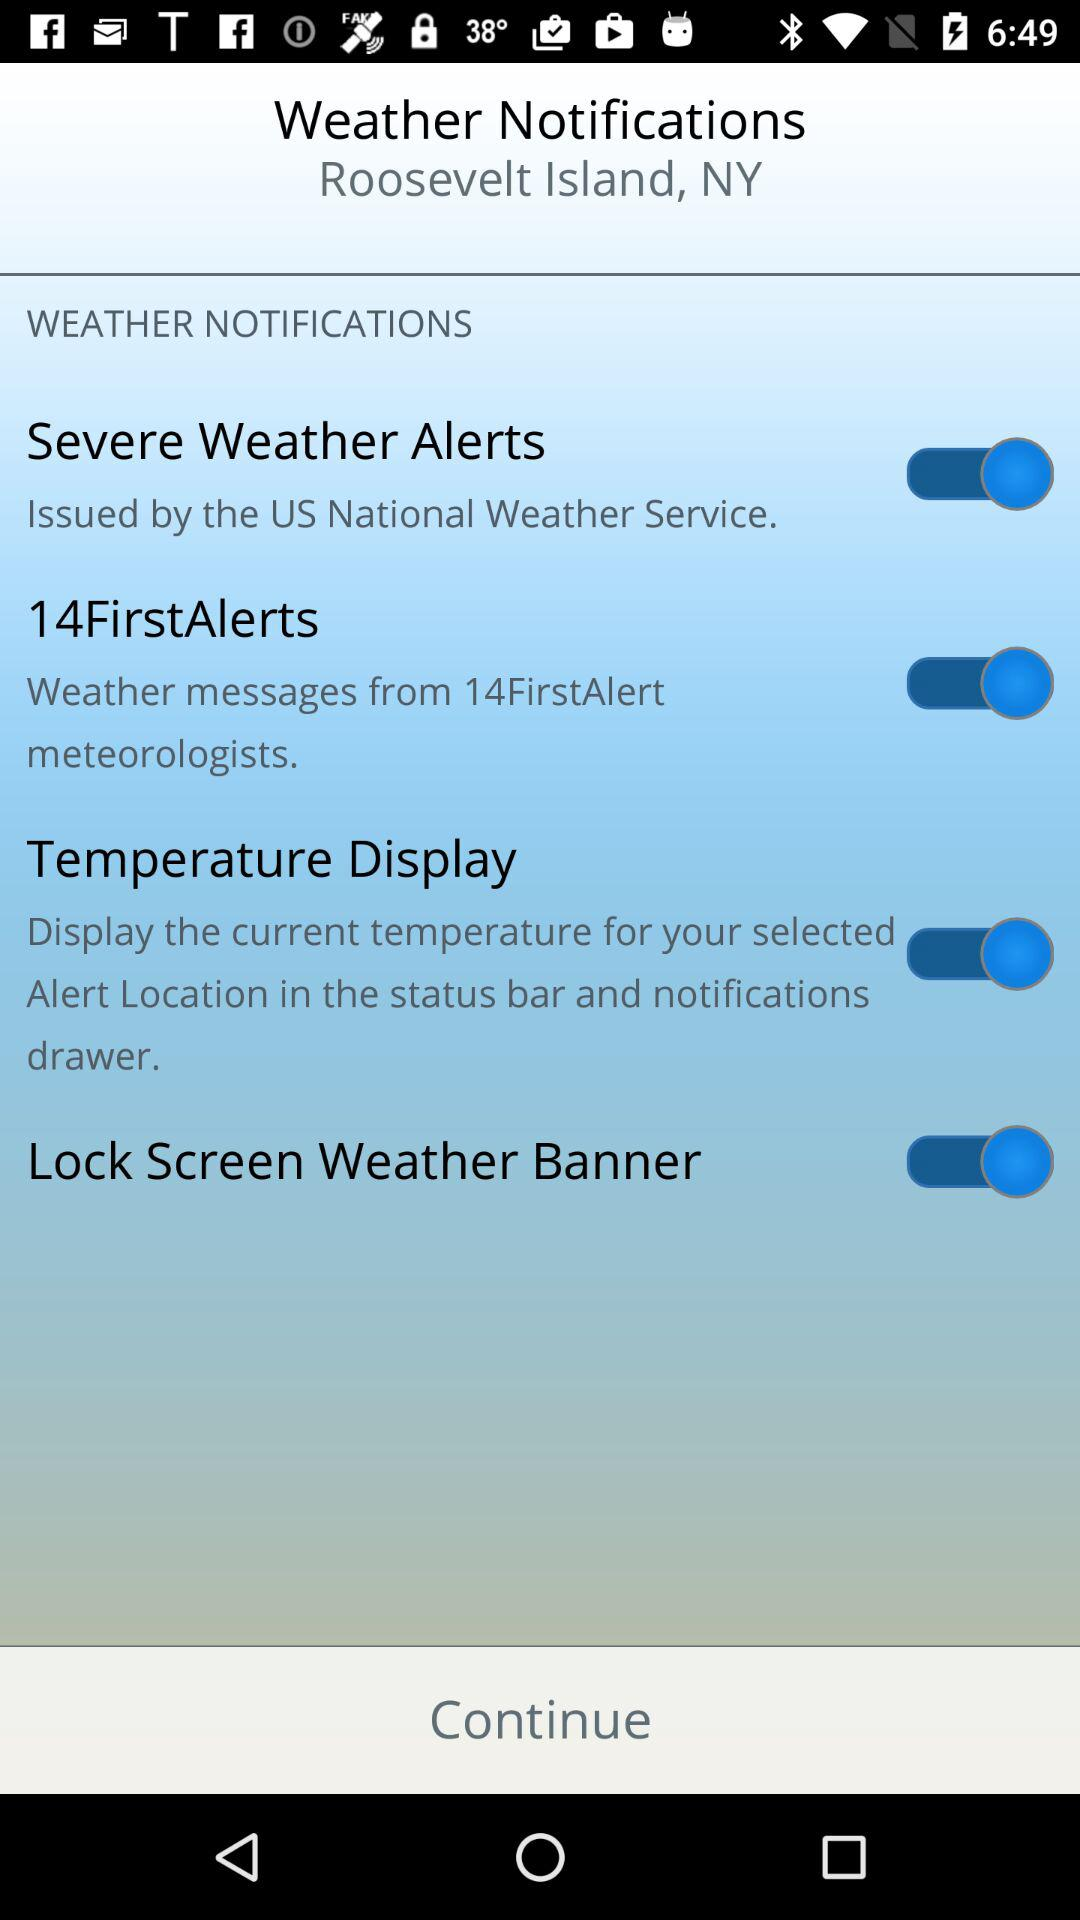What is the current status of the "Severe Weather Alerts"? The status is "on". 